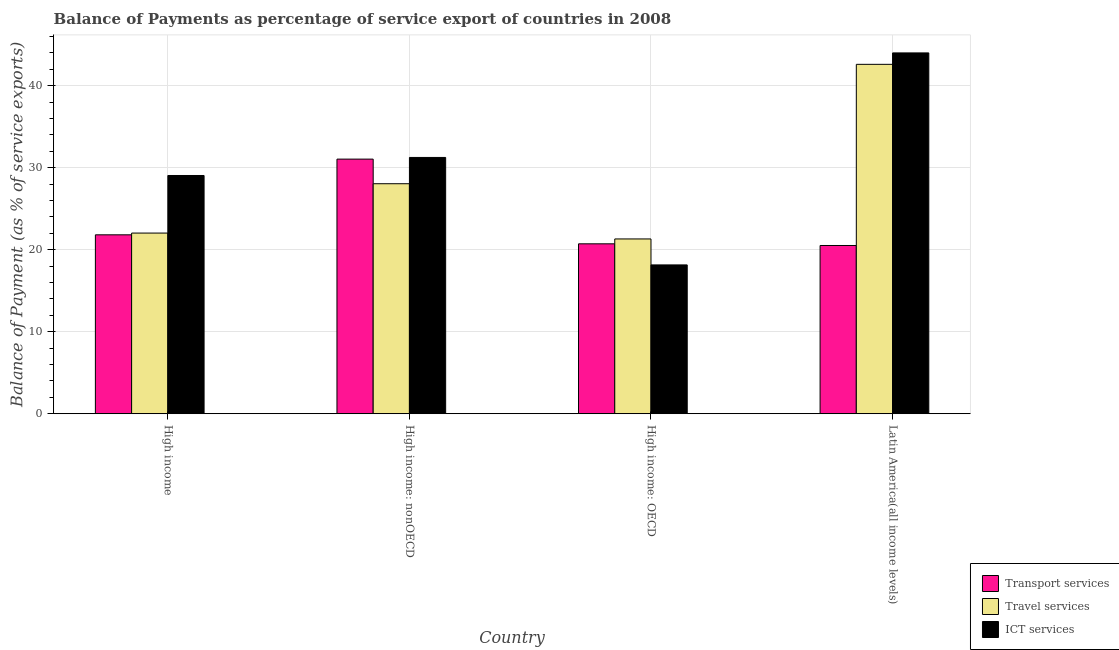Are the number of bars per tick equal to the number of legend labels?
Make the answer very short. Yes. How many bars are there on the 3rd tick from the left?
Provide a succinct answer. 3. How many bars are there on the 2nd tick from the right?
Provide a succinct answer. 3. What is the label of the 4th group of bars from the left?
Offer a terse response. Latin America(all income levels). In how many cases, is the number of bars for a given country not equal to the number of legend labels?
Your response must be concise. 0. What is the balance of payment of travel services in High income?
Ensure brevity in your answer.  22.03. Across all countries, what is the maximum balance of payment of transport services?
Make the answer very short. 31.05. Across all countries, what is the minimum balance of payment of travel services?
Your answer should be very brief. 21.32. In which country was the balance of payment of travel services maximum?
Keep it short and to the point. Latin America(all income levels). In which country was the balance of payment of transport services minimum?
Your response must be concise. Latin America(all income levels). What is the total balance of payment of travel services in the graph?
Provide a short and direct response. 114.01. What is the difference between the balance of payment of ict services in High income: OECD and that in Latin America(all income levels)?
Make the answer very short. -25.85. What is the difference between the balance of payment of travel services in Latin America(all income levels) and the balance of payment of ict services in High income: nonOECD?
Your response must be concise. 11.36. What is the average balance of payment of ict services per country?
Keep it short and to the point. 30.62. What is the difference between the balance of payment of transport services and balance of payment of ict services in High income: OECD?
Offer a very short reply. 2.57. In how many countries, is the balance of payment of travel services greater than 24 %?
Your answer should be compact. 2. What is the ratio of the balance of payment of transport services in High income: OECD to that in Latin America(all income levels)?
Give a very brief answer. 1.01. Is the balance of payment of ict services in High income less than that in Latin America(all income levels)?
Your answer should be very brief. Yes. Is the difference between the balance of payment of transport services in High income: nonOECD and Latin America(all income levels) greater than the difference between the balance of payment of ict services in High income: nonOECD and Latin America(all income levels)?
Provide a succinct answer. Yes. What is the difference between the highest and the second highest balance of payment of ict services?
Offer a very short reply. 12.75. What is the difference between the highest and the lowest balance of payment of travel services?
Your answer should be compact. 21.29. What does the 3rd bar from the left in High income: nonOECD represents?
Give a very brief answer. ICT services. What does the 1st bar from the right in High income: nonOECD represents?
Give a very brief answer. ICT services. How many countries are there in the graph?
Offer a terse response. 4. What is the difference between two consecutive major ticks on the Y-axis?
Give a very brief answer. 10. Are the values on the major ticks of Y-axis written in scientific E-notation?
Provide a short and direct response. No. Does the graph contain grids?
Offer a very short reply. Yes. Where does the legend appear in the graph?
Provide a succinct answer. Bottom right. How many legend labels are there?
Offer a terse response. 3. What is the title of the graph?
Your answer should be compact. Balance of Payments as percentage of service export of countries in 2008. Does "Primary" appear as one of the legend labels in the graph?
Ensure brevity in your answer.  No. What is the label or title of the Y-axis?
Your answer should be very brief. Balance of Payment (as % of service exports). What is the Balance of Payment (as % of service exports) in Transport services in High income?
Provide a short and direct response. 21.82. What is the Balance of Payment (as % of service exports) in Travel services in High income?
Provide a short and direct response. 22.03. What is the Balance of Payment (as % of service exports) in ICT services in High income?
Provide a succinct answer. 29.06. What is the Balance of Payment (as % of service exports) in Transport services in High income: nonOECD?
Provide a short and direct response. 31.05. What is the Balance of Payment (as % of service exports) in Travel services in High income: nonOECD?
Your response must be concise. 28.05. What is the Balance of Payment (as % of service exports) in ICT services in High income: nonOECD?
Offer a very short reply. 31.26. What is the Balance of Payment (as % of service exports) of Transport services in High income: OECD?
Give a very brief answer. 20.72. What is the Balance of Payment (as % of service exports) in Travel services in High income: OECD?
Your response must be concise. 21.32. What is the Balance of Payment (as % of service exports) of ICT services in High income: OECD?
Give a very brief answer. 18.15. What is the Balance of Payment (as % of service exports) of Transport services in Latin America(all income levels)?
Your answer should be very brief. 20.52. What is the Balance of Payment (as % of service exports) of Travel services in Latin America(all income levels)?
Give a very brief answer. 42.61. What is the Balance of Payment (as % of service exports) in ICT services in Latin America(all income levels)?
Your response must be concise. 44. Across all countries, what is the maximum Balance of Payment (as % of service exports) in Transport services?
Your answer should be very brief. 31.05. Across all countries, what is the maximum Balance of Payment (as % of service exports) in Travel services?
Give a very brief answer. 42.61. Across all countries, what is the maximum Balance of Payment (as % of service exports) of ICT services?
Offer a very short reply. 44. Across all countries, what is the minimum Balance of Payment (as % of service exports) in Transport services?
Make the answer very short. 20.52. Across all countries, what is the minimum Balance of Payment (as % of service exports) in Travel services?
Keep it short and to the point. 21.32. Across all countries, what is the minimum Balance of Payment (as % of service exports) in ICT services?
Make the answer very short. 18.15. What is the total Balance of Payment (as % of service exports) in Transport services in the graph?
Ensure brevity in your answer.  94.11. What is the total Balance of Payment (as % of service exports) of Travel services in the graph?
Provide a succinct answer. 114.01. What is the total Balance of Payment (as % of service exports) of ICT services in the graph?
Make the answer very short. 122.47. What is the difference between the Balance of Payment (as % of service exports) of Transport services in High income and that in High income: nonOECD?
Your answer should be very brief. -9.23. What is the difference between the Balance of Payment (as % of service exports) in Travel services in High income and that in High income: nonOECD?
Your answer should be compact. -6.02. What is the difference between the Balance of Payment (as % of service exports) in ICT services in High income and that in High income: nonOECD?
Your answer should be compact. -2.2. What is the difference between the Balance of Payment (as % of service exports) of Transport services in High income and that in High income: OECD?
Keep it short and to the point. 1.1. What is the difference between the Balance of Payment (as % of service exports) of Travel services in High income and that in High income: OECD?
Provide a short and direct response. 0.72. What is the difference between the Balance of Payment (as % of service exports) of ICT services in High income and that in High income: OECD?
Make the answer very short. 10.91. What is the difference between the Balance of Payment (as % of service exports) of Transport services in High income and that in Latin America(all income levels)?
Keep it short and to the point. 1.3. What is the difference between the Balance of Payment (as % of service exports) of Travel services in High income and that in Latin America(all income levels)?
Your answer should be very brief. -20.58. What is the difference between the Balance of Payment (as % of service exports) in ICT services in High income and that in Latin America(all income levels)?
Provide a succinct answer. -14.95. What is the difference between the Balance of Payment (as % of service exports) of Transport services in High income: nonOECD and that in High income: OECD?
Your response must be concise. 10.33. What is the difference between the Balance of Payment (as % of service exports) of Travel services in High income: nonOECD and that in High income: OECD?
Provide a succinct answer. 6.73. What is the difference between the Balance of Payment (as % of service exports) of ICT services in High income: nonOECD and that in High income: OECD?
Make the answer very short. 13.11. What is the difference between the Balance of Payment (as % of service exports) in Transport services in High income: nonOECD and that in Latin America(all income levels)?
Offer a terse response. 10.53. What is the difference between the Balance of Payment (as % of service exports) in Travel services in High income: nonOECD and that in Latin America(all income levels)?
Offer a very short reply. -14.56. What is the difference between the Balance of Payment (as % of service exports) of ICT services in High income: nonOECD and that in Latin America(all income levels)?
Provide a succinct answer. -12.75. What is the difference between the Balance of Payment (as % of service exports) in Transport services in High income: OECD and that in Latin America(all income levels)?
Offer a very short reply. 0.2. What is the difference between the Balance of Payment (as % of service exports) in Travel services in High income: OECD and that in Latin America(all income levels)?
Offer a terse response. -21.29. What is the difference between the Balance of Payment (as % of service exports) in ICT services in High income: OECD and that in Latin America(all income levels)?
Ensure brevity in your answer.  -25.85. What is the difference between the Balance of Payment (as % of service exports) in Transport services in High income and the Balance of Payment (as % of service exports) in Travel services in High income: nonOECD?
Ensure brevity in your answer.  -6.23. What is the difference between the Balance of Payment (as % of service exports) in Transport services in High income and the Balance of Payment (as % of service exports) in ICT services in High income: nonOECD?
Offer a very short reply. -9.44. What is the difference between the Balance of Payment (as % of service exports) of Travel services in High income and the Balance of Payment (as % of service exports) of ICT services in High income: nonOECD?
Provide a succinct answer. -9.22. What is the difference between the Balance of Payment (as % of service exports) in Transport services in High income and the Balance of Payment (as % of service exports) in Travel services in High income: OECD?
Provide a short and direct response. 0.5. What is the difference between the Balance of Payment (as % of service exports) in Transport services in High income and the Balance of Payment (as % of service exports) in ICT services in High income: OECD?
Your answer should be compact. 3.67. What is the difference between the Balance of Payment (as % of service exports) in Travel services in High income and the Balance of Payment (as % of service exports) in ICT services in High income: OECD?
Give a very brief answer. 3.88. What is the difference between the Balance of Payment (as % of service exports) in Transport services in High income and the Balance of Payment (as % of service exports) in Travel services in Latin America(all income levels)?
Offer a terse response. -20.79. What is the difference between the Balance of Payment (as % of service exports) in Transport services in High income and the Balance of Payment (as % of service exports) in ICT services in Latin America(all income levels)?
Your response must be concise. -22.18. What is the difference between the Balance of Payment (as % of service exports) of Travel services in High income and the Balance of Payment (as % of service exports) of ICT services in Latin America(all income levels)?
Your answer should be very brief. -21.97. What is the difference between the Balance of Payment (as % of service exports) in Transport services in High income: nonOECD and the Balance of Payment (as % of service exports) in Travel services in High income: OECD?
Give a very brief answer. 9.74. What is the difference between the Balance of Payment (as % of service exports) in Transport services in High income: nonOECD and the Balance of Payment (as % of service exports) in ICT services in High income: OECD?
Ensure brevity in your answer.  12.9. What is the difference between the Balance of Payment (as % of service exports) in Travel services in High income: nonOECD and the Balance of Payment (as % of service exports) in ICT services in High income: OECD?
Give a very brief answer. 9.9. What is the difference between the Balance of Payment (as % of service exports) of Transport services in High income: nonOECD and the Balance of Payment (as % of service exports) of Travel services in Latin America(all income levels)?
Your response must be concise. -11.56. What is the difference between the Balance of Payment (as % of service exports) of Transport services in High income: nonOECD and the Balance of Payment (as % of service exports) of ICT services in Latin America(all income levels)?
Make the answer very short. -12.95. What is the difference between the Balance of Payment (as % of service exports) of Travel services in High income: nonOECD and the Balance of Payment (as % of service exports) of ICT services in Latin America(all income levels)?
Give a very brief answer. -15.95. What is the difference between the Balance of Payment (as % of service exports) of Transport services in High income: OECD and the Balance of Payment (as % of service exports) of Travel services in Latin America(all income levels)?
Offer a very short reply. -21.89. What is the difference between the Balance of Payment (as % of service exports) of Transport services in High income: OECD and the Balance of Payment (as % of service exports) of ICT services in Latin America(all income levels)?
Offer a very short reply. -23.28. What is the difference between the Balance of Payment (as % of service exports) of Travel services in High income: OECD and the Balance of Payment (as % of service exports) of ICT services in Latin America(all income levels)?
Offer a very short reply. -22.69. What is the average Balance of Payment (as % of service exports) in Transport services per country?
Make the answer very short. 23.53. What is the average Balance of Payment (as % of service exports) of Travel services per country?
Offer a very short reply. 28.5. What is the average Balance of Payment (as % of service exports) of ICT services per country?
Provide a succinct answer. 30.62. What is the difference between the Balance of Payment (as % of service exports) in Transport services and Balance of Payment (as % of service exports) in Travel services in High income?
Your answer should be compact. -0.21. What is the difference between the Balance of Payment (as % of service exports) in Transport services and Balance of Payment (as % of service exports) in ICT services in High income?
Provide a succinct answer. -7.24. What is the difference between the Balance of Payment (as % of service exports) in Travel services and Balance of Payment (as % of service exports) in ICT services in High income?
Provide a succinct answer. -7.02. What is the difference between the Balance of Payment (as % of service exports) of Transport services and Balance of Payment (as % of service exports) of Travel services in High income: nonOECD?
Your answer should be very brief. 3. What is the difference between the Balance of Payment (as % of service exports) in Transport services and Balance of Payment (as % of service exports) in ICT services in High income: nonOECD?
Your answer should be compact. -0.2. What is the difference between the Balance of Payment (as % of service exports) in Travel services and Balance of Payment (as % of service exports) in ICT services in High income: nonOECD?
Provide a short and direct response. -3.2. What is the difference between the Balance of Payment (as % of service exports) in Transport services and Balance of Payment (as % of service exports) in Travel services in High income: OECD?
Provide a succinct answer. -0.6. What is the difference between the Balance of Payment (as % of service exports) of Transport services and Balance of Payment (as % of service exports) of ICT services in High income: OECD?
Provide a short and direct response. 2.57. What is the difference between the Balance of Payment (as % of service exports) in Travel services and Balance of Payment (as % of service exports) in ICT services in High income: OECD?
Provide a succinct answer. 3.17. What is the difference between the Balance of Payment (as % of service exports) of Transport services and Balance of Payment (as % of service exports) of Travel services in Latin America(all income levels)?
Provide a succinct answer. -22.09. What is the difference between the Balance of Payment (as % of service exports) in Transport services and Balance of Payment (as % of service exports) in ICT services in Latin America(all income levels)?
Your response must be concise. -23.48. What is the difference between the Balance of Payment (as % of service exports) of Travel services and Balance of Payment (as % of service exports) of ICT services in Latin America(all income levels)?
Your answer should be compact. -1.39. What is the ratio of the Balance of Payment (as % of service exports) in Transport services in High income to that in High income: nonOECD?
Ensure brevity in your answer.  0.7. What is the ratio of the Balance of Payment (as % of service exports) in Travel services in High income to that in High income: nonOECD?
Your response must be concise. 0.79. What is the ratio of the Balance of Payment (as % of service exports) of ICT services in High income to that in High income: nonOECD?
Your answer should be compact. 0.93. What is the ratio of the Balance of Payment (as % of service exports) of Transport services in High income to that in High income: OECD?
Make the answer very short. 1.05. What is the ratio of the Balance of Payment (as % of service exports) of Travel services in High income to that in High income: OECD?
Make the answer very short. 1.03. What is the ratio of the Balance of Payment (as % of service exports) in ICT services in High income to that in High income: OECD?
Provide a succinct answer. 1.6. What is the ratio of the Balance of Payment (as % of service exports) of Transport services in High income to that in Latin America(all income levels)?
Make the answer very short. 1.06. What is the ratio of the Balance of Payment (as % of service exports) in Travel services in High income to that in Latin America(all income levels)?
Give a very brief answer. 0.52. What is the ratio of the Balance of Payment (as % of service exports) in ICT services in High income to that in Latin America(all income levels)?
Provide a short and direct response. 0.66. What is the ratio of the Balance of Payment (as % of service exports) in Transport services in High income: nonOECD to that in High income: OECD?
Provide a succinct answer. 1.5. What is the ratio of the Balance of Payment (as % of service exports) of Travel services in High income: nonOECD to that in High income: OECD?
Offer a terse response. 1.32. What is the ratio of the Balance of Payment (as % of service exports) of ICT services in High income: nonOECD to that in High income: OECD?
Offer a very short reply. 1.72. What is the ratio of the Balance of Payment (as % of service exports) of Transport services in High income: nonOECD to that in Latin America(all income levels)?
Give a very brief answer. 1.51. What is the ratio of the Balance of Payment (as % of service exports) in Travel services in High income: nonOECD to that in Latin America(all income levels)?
Your answer should be compact. 0.66. What is the ratio of the Balance of Payment (as % of service exports) in ICT services in High income: nonOECD to that in Latin America(all income levels)?
Your answer should be very brief. 0.71. What is the ratio of the Balance of Payment (as % of service exports) of Transport services in High income: OECD to that in Latin America(all income levels)?
Make the answer very short. 1.01. What is the ratio of the Balance of Payment (as % of service exports) in Travel services in High income: OECD to that in Latin America(all income levels)?
Make the answer very short. 0.5. What is the ratio of the Balance of Payment (as % of service exports) in ICT services in High income: OECD to that in Latin America(all income levels)?
Provide a short and direct response. 0.41. What is the difference between the highest and the second highest Balance of Payment (as % of service exports) of Transport services?
Make the answer very short. 9.23. What is the difference between the highest and the second highest Balance of Payment (as % of service exports) in Travel services?
Your answer should be compact. 14.56. What is the difference between the highest and the second highest Balance of Payment (as % of service exports) of ICT services?
Keep it short and to the point. 12.75. What is the difference between the highest and the lowest Balance of Payment (as % of service exports) of Transport services?
Offer a terse response. 10.53. What is the difference between the highest and the lowest Balance of Payment (as % of service exports) of Travel services?
Your answer should be compact. 21.29. What is the difference between the highest and the lowest Balance of Payment (as % of service exports) in ICT services?
Your answer should be compact. 25.85. 